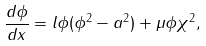<formula> <loc_0><loc_0><loc_500><loc_500>\frac { d \phi } { d x } = l \phi ( \phi ^ { 2 } - a ^ { 2 } ) + \mu \phi \chi ^ { 2 } ,</formula> 